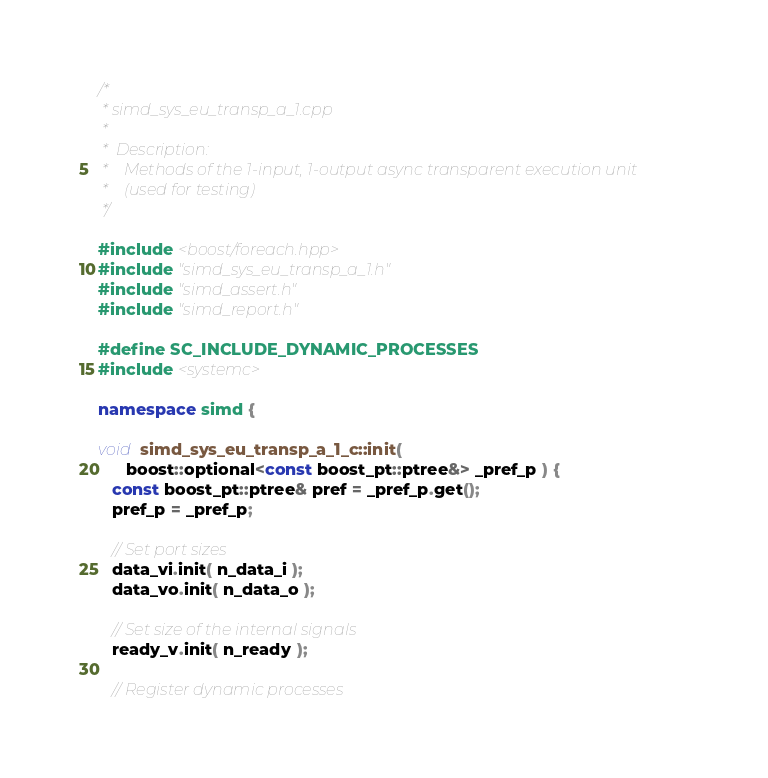<code> <loc_0><loc_0><loc_500><loc_500><_C++_>/*
 * simd_sys_eu_transp_a_1.cpp
 *
 *  Description:
 *    Methods of the 1-input, 1-output async transparent execution unit
 *    (used for testing)
 */

#include <boost/foreach.hpp>
#include "simd_sys_eu_transp_a_1.h"
#include "simd_assert.h"
#include "simd_report.h"

#define SC_INCLUDE_DYNAMIC_PROCESSES
#include <systemc>

namespace simd {

void simd_sys_eu_transp_a_1_c::init(
      boost::optional<const boost_pt::ptree&> _pref_p ) {
   const boost_pt::ptree& pref = _pref_p.get();
   pref_p = _pref_p;

   // Set port sizes
   data_vi.init( n_data_i );
   data_vo.init( n_data_o );

   // Set size of the internal signals
   ready_v.init( n_ready );

   // Register dynamic processes</code> 